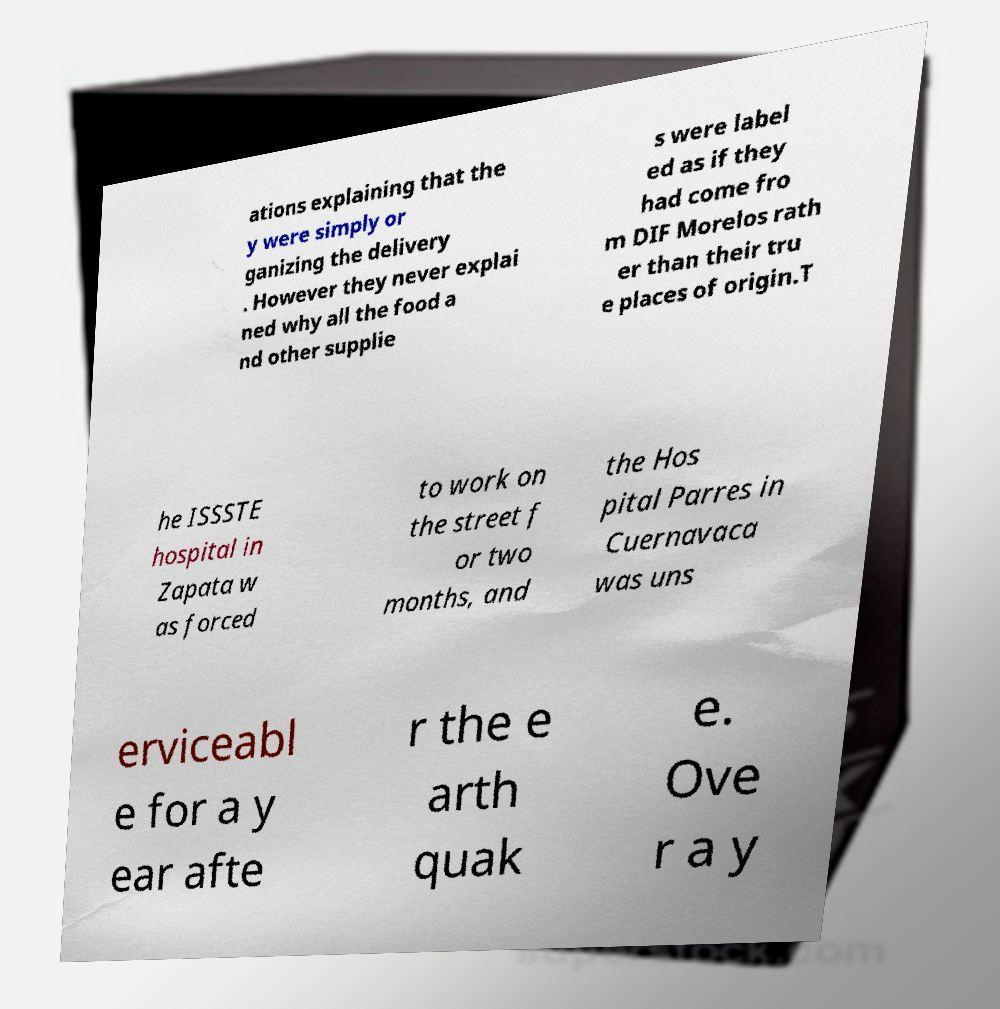Could you assist in decoding the text presented in this image and type it out clearly? ations explaining that the y were simply or ganizing the delivery . However they never explai ned why all the food a nd other supplie s were label ed as if they had come fro m DIF Morelos rath er than their tru e places of origin.T he ISSSTE hospital in Zapata w as forced to work on the street f or two months, and the Hos pital Parres in Cuernavaca was uns erviceabl e for a y ear afte r the e arth quak e. Ove r a y 